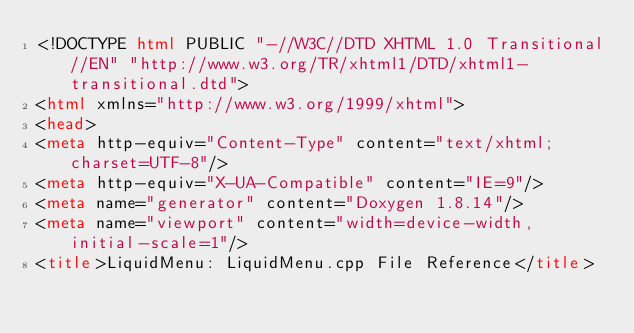Convert code to text. <code><loc_0><loc_0><loc_500><loc_500><_HTML_><!DOCTYPE html PUBLIC "-//W3C//DTD XHTML 1.0 Transitional//EN" "http://www.w3.org/TR/xhtml1/DTD/xhtml1-transitional.dtd">
<html xmlns="http://www.w3.org/1999/xhtml">
<head>
<meta http-equiv="Content-Type" content="text/xhtml;charset=UTF-8"/>
<meta http-equiv="X-UA-Compatible" content="IE=9"/>
<meta name="generator" content="Doxygen 1.8.14"/>
<meta name="viewport" content="width=device-width, initial-scale=1"/>
<title>LiquidMenu: LiquidMenu.cpp File Reference</title></code> 